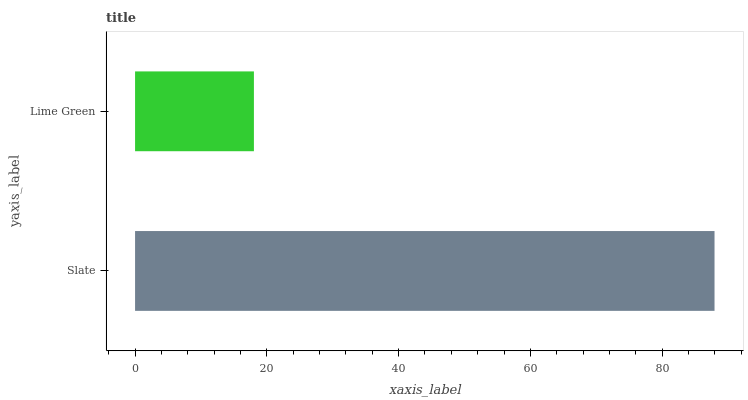Is Lime Green the minimum?
Answer yes or no. Yes. Is Slate the maximum?
Answer yes or no. Yes. Is Lime Green the maximum?
Answer yes or no. No. Is Slate greater than Lime Green?
Answer yes or no. Yes. Is Lime Green less than Slate?
Answer yes or no. Yes. Is Lime Green greater than Slate?
Answer yes or no. No. Is Slate less than Lime Green?
Answer yes or no. No. Is Slate the high median?
Answer yes or no. Yes. Is Lime Green the low median?
Answer yes or no. Yes. Is Lime Green the high median?
Answer yes or no. No. Is Slate the low median?
Answer yes or no. No. 